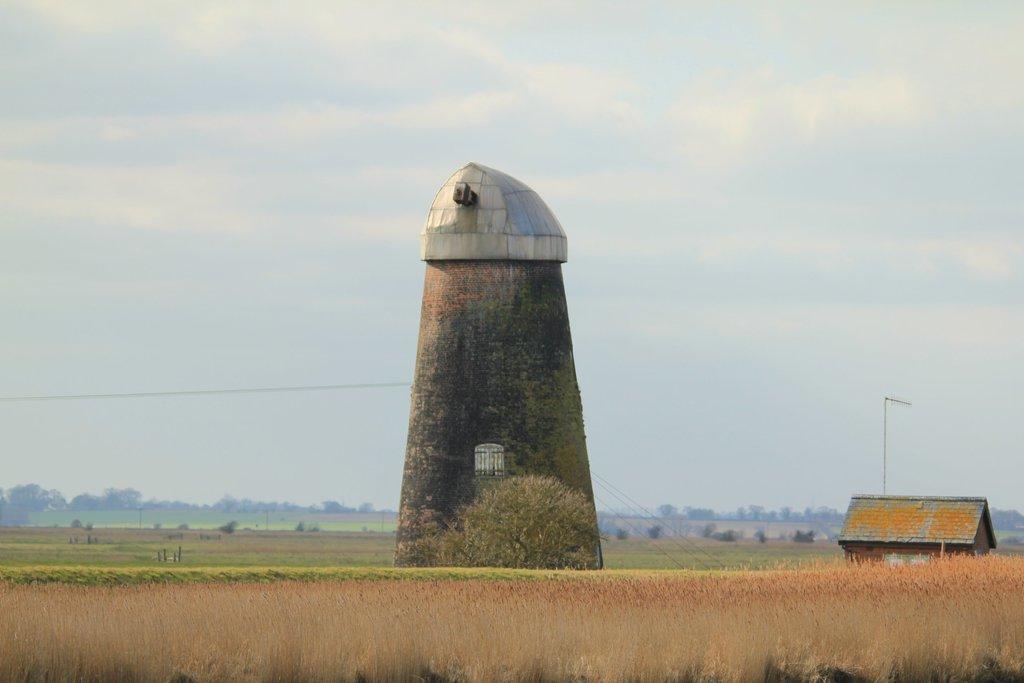Could you give a brief overview of what you see in this image? In this image there is a building. On the ground there are plants. On the right side there is another building. In the background there are trees and sky. 